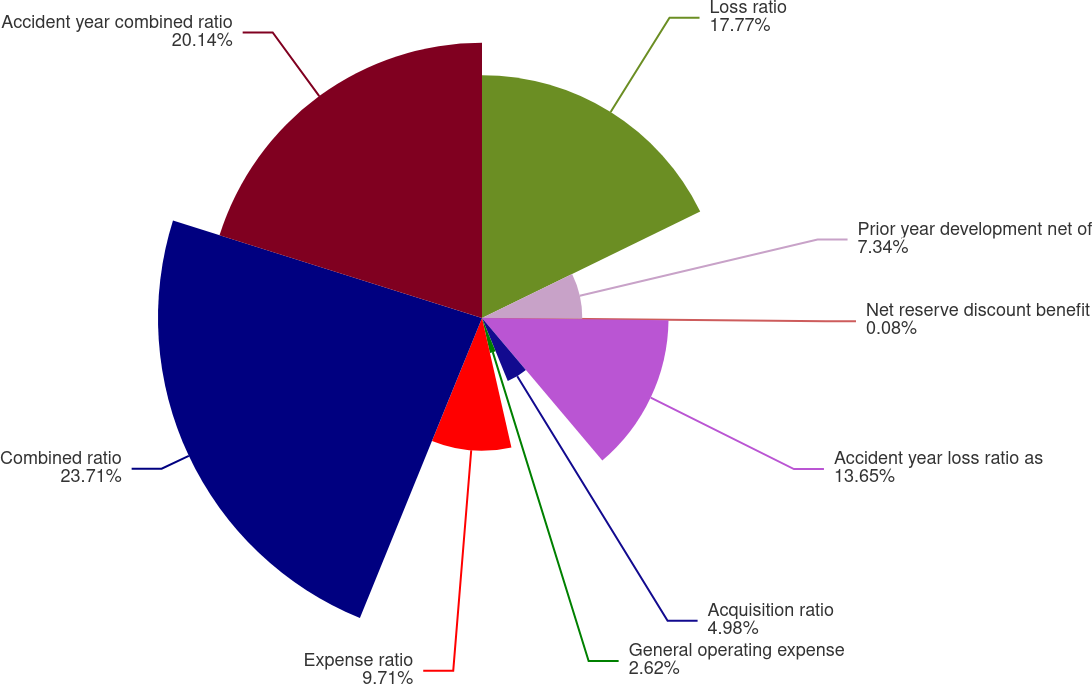Convert chart. <chart><loc_0><loc_0><loc_500><loc_500><pie_chart><fcel>Loss ratio<fcel>Prior year development net of<fcel>Net reserve discount benefit<fcel>Accident year loss ratio as<fcel>Acquisition ratio<fcel>General operating expense<fcel>Expense ratio<fcel>Combined ratio<fcel>Accident year combined ratio<nl><fcel>17.77%<fcel>7.34%<fcel>0.08%<fcel>13.65%<fcel>4.98%<fcel>2.62%<fcel>9.71%<fcel>23.71%<fcel>20.14%<nl></chart> 